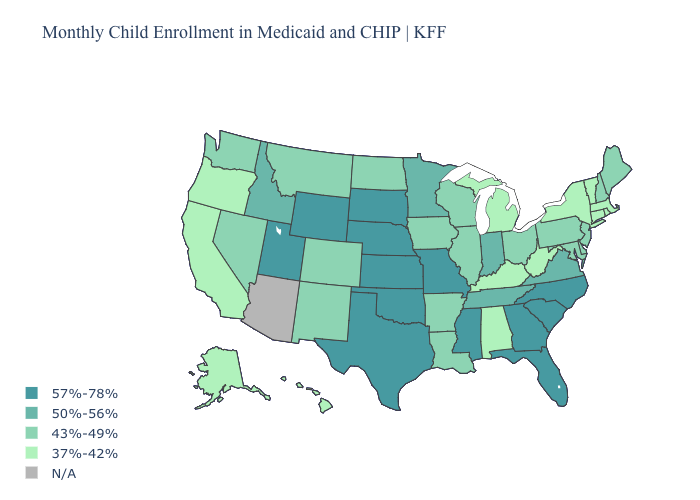How many symbols are there in the legend?
Concise answer only. 5. What is the lowest value in the USA?
Concise answer only. 37%-42%. Name the states that have a value in the range N/A?
Answer briefly. Arizona. What is the lowest value in the West?
Short answer required. 37%-42%. What is the value of Nebraska?
Quick response, please. 57%-78%. Name the states that have a value in the range 37%-42%?
Write a very short answer. Alabama, Alaska, California, Connecticut, Hawaii, Kentucky, Massachusetts, Michigan, New York, Oregon, Rhode Island, Vermont, West Virginia. What is the highest value in states that border Connecticut?
Give a very brief answer. 37%-42%. Name the states that have a value in the range 43%-49%?
Concise answer only. Arkansas, Colorado, Delaware, Illinois, Iowa, Louisiana, Maine, Maryland, Montana, Nevada, New Hampshire, New Jersey, New Mexico, North Dakota, Ohio, Pennsylvania, Washington, Wisconsin. Is the legend a continuous bar?
Be succinct. No. What is the value of Hawaii?
Write a very short answer. 37%-42%. Does the map have missing data?
Quick response, please. Yes. Name the states that have a value in the range 37%-42%?
Concise answer only. Alabama, Alaska, California, Connecticut, Hawaii, Kentucky, Massachusetts, Michigan, New York, Oregon, Rhode Island, Vermont, West Virginia. Is the legend a continuous bar?
Quick response, please. No. Among the states that border South Carolina , which have the lowest value?
Concise answer only. Georgia, North Carolina. What is the lowest value in states that border Wyoming?
Answer briefly. 43%-49%. 